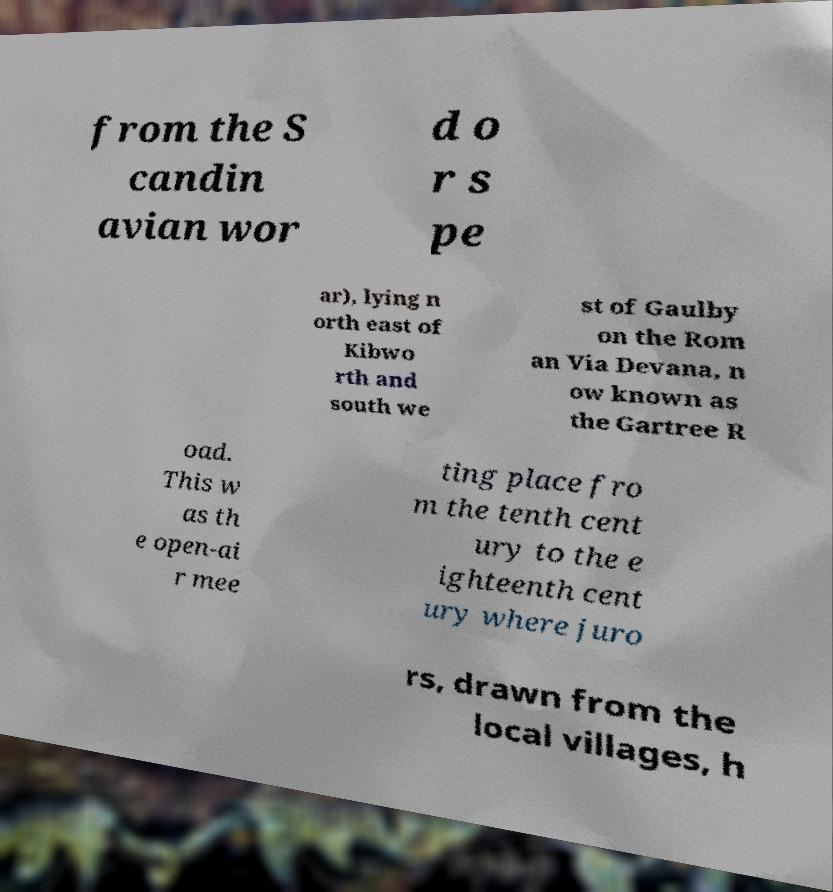Can you accurately transcribe the text from the provided image for me? from the S candin avian wor d o r s pe ar), lying n orth east of Kibwo rth and south we st of Gaulby on the Rom an Via Devana, n ow known as the Gartree R oad. This w as th e open-ai r mee ting place fro m the tenth cent ury to the e ighteenth cent ury where juro rs, drawn from the local villages, h 